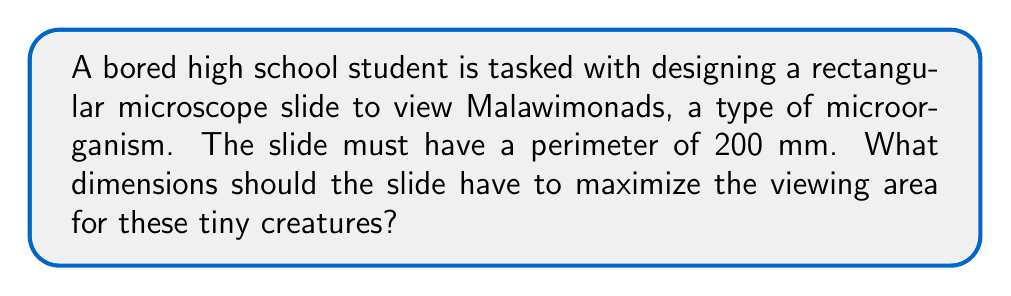Give your solution to this math problem. Let's approach this step-by-step:

1) Let's define our variables:
   $w$ = width of the slide
   $l$ = length of the slide

2) We know the perimeter is 200 mm, so we can write:
   $2w + 2l = 200$

3) Solving for $w$:
   $w = 100 - l$

4) The area of the slide is given by $A = w * l$. Substituting our expression for $w$:
   $A = (100 - l) * l = 100l - l^2$

5) To find the maximum area, we need to find where the derivative of $A$ with respect to $l$ is zero:
   $\frac{dA}{dl} = 100 - 2l$

6) Setting this equal to zero:
   $100 - 2l = 0$
   $2l = 100$
   $l = 50$

7) We can confirm this is a maximum by checking the second derivative:
   $\frac{d^2A}{dl^2} = -2$, which is negative, confirming a maximum.

8) If $l = 50$, then $w = 100 - 50 = 50$

Therefore, the slide should be a square with sides of 50 mm to maximize the viewing area.
Answer: The optimal dimensions for the microscope slide are 50 mm x 50 mm, creating a square with a maximum viewing area of 2500 mm². 